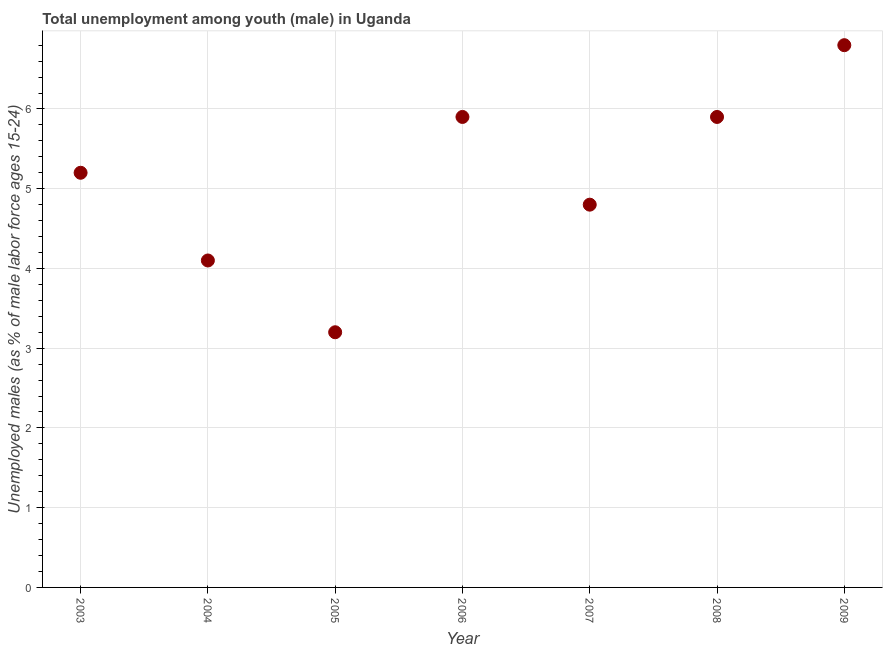What is the unemployed male youth population in 2007?
Make the answer very short. 4.8. Across all years, what is the maximum unemployed male youth population?
Your response must be concise. 6.8. Across all years, what is the minimum unemployed male youth population?
Your answer should be compact. 3.2. In which year was the unemployed male youth population minimum?
Offer a terse response. 2005. What is the sum of the unemployed male youth population?
Your answer should be very brief. 35.9. What is the difference between the unemployed male youth population in 2005 and 2006?
Your answer should be very brief. -2.7. What is the average unemployed male youth population per year?
Give a very brief answer. 5.13. What is the median unemployed male youth population?
Make the answer very short. 5.2. In how many years, is the unemployed male youth population greater than 1.8 %?
Offer a terse response. 7. What is the ratio of the unemployed male youth population in 2005 to that in 2008?
Your response must be concise. 0.54. Is the difference between the unemployed male youth population in 2005 and 2007 greater than the difference between any two years?
Provide a short and direct response. No. What is the difference between the highest and the second highest unemployed male youth population?
Give a very brief answer. 0.9. Is the sum of the unemployed male youth population in 2006 and 2007 greater than the maximum unemployed male youth population across all years?
Make the answer very short. Yes. What is the difference between the highest and the lowest unemployed male youth population?
Your response must be concise. 3.6. Are the values on the major ticks of Y-axis written in scientific E-notation?
Offer a very short reply. No. What is the title of the graph?
Make the answer very short. Total unemployment among youth (male) in Uganda. What is the label or title of the X-axis?
Keep it short and to the point. Year. What is the label or title of the Y-axis?
Ensure brevity in your answer.  Unemployed males (as % of male labor force ages 15-24). What is the Unemployed males (as % of male labor force ages 15-24) in 2003?
Keep it short and to the point. 5.2. What is the Unemployed males (as % of male labor force ages 15-24) in 2004?
Your answer should be compact. 4.1. What is the Unemployed males (as % of male labor force ages 15-24) in 2005?
Your response must be concise. 3.2. What is the Unemployed males (as % of male labor force ages 15-24) in 2006?
Provide a short and direct response. 5.9. What is the Unemployed males (as % of male labor force ages 15-24) in 2007?
Ensure brevity in your answer.  4.8. What is the Unemployed males (as % of male labor force ages 15-24) in 2008?
Provide a short and direct response. 5.9. What is the Unemployed males (as % of male labor force ages 15-24) in 2009?
Keep it short and to the point. 6.8. What is the difference between the Unemployed males (as % of male labor force ages 15-24) in 2003 and 2007?
Provide a short and direct response. 0.4. What is the difference between the Unemployed males (as % of male labor force ages 15-24) in 2003 and 2009?
Your answer should be very brief. -1.6. What is the difference between the Unemployed males (as % of male labor force ages 15-24) in 2004 and 2005?
Provide a short and direct response. 0.9. What is the difference between the Unemployed males (as % of male labor force ages 15-24) in 2004 and 2006?
Keep it short and to the point. -1.8. What is the difference between the Unemployed males (as % of male labor force ages 15-24) in 2004 and 2007?
Provide a short and direct response. -0.7. What is the difference between the Unemployed males (as % of male labor force ages 15-24) in 2004 and 2009?
Your response must be concise. -2.7. What is the difference between the Unemployed males (as % of male labor force ages 15-24) in 2005 and 2006?
Provide a succinct answer. -2.7. What is the difference between the Unemployed males (as % of male labor force ages 15-24) in 2005 and 2008?
Keep it short and to the point. -2.7. What is the difference between the Unemployed males (as % of male labor force ages 15-24) in 2005 and 2009?
Give a very brief answer. -3.6. What is the difference between the Unemployed males (as % of male labor force ages 15-24) in 2006 and 2007?
Offer a very short reply. 1.1. What is the difference between the Unemployed males (as % of male labor force ages 15-24) in 2006 and 2008?
Make the answer very short. 0. What is the difference between the Unemployed males (as % of male labor force ages 15-24) in 2006 and 2009?
Your answer should be compact. -0.9. What is the difference between the Unemployed males (as % of male labor force ages 15-24) in 2007 and 2008?
Keep it short and to the point. -1.1. What is the difference between the Unemployed males (as % of male labor force ages 15-24) in 2007 and 2009?
Give a very brief answer. -2. What is the ratio of the Unemployed males (as % of male labor force ages 15-24) in 2003 to that in 2004?
Provide a succinct answer. 1.27. What is the ratio of the Unemployed males (as % of male labor force ages 15-24) in 2003 to that in 2005?
Provide a succinct answer. 1.62. What is the ratio of the Unemployed males (as % of male labor force ages 15-24) in 2003 to that in 2006?
Make the answer very short. 0.88. What is the ratio of the Unemployed males (as % of male labor force ages 15-24) in 2003 to that in 2007?
Provide a short and direct response. 1.08. What is the ratio of the Unemployed males (as % of male labor force ages 15-24) in 2003 to that in 2008?
Your response must be concise. 0.88. What is the ratio of the Unemployed males (as % of male labor force ages 15-24) in 2003 to that in 2009?
Provide a succinct answer. 0.77. What is the ratio of the Unemployed males (as % of male labor force ages 15-24) in 2004 to that in 2005?
Give a very brief answer. 1.28. What is the ratio of the Unemployed males (as % of male labor force ages 15-24) in 2004 to that in 2006?
Keep it short and to the point. 0.69. What is the ratio of the Unemployed males (as % of male labor force ages 15-24) in 2004 to that in 2007?
Provide a short and direct response. 0.85. What is the ratio of the Unemployed males (as % of male labor force ages 15-24) in 2004 to that in 2008?
Your answer should be compact. 0.69. What is the ratio of the Unemployed males (as % of male labor force ages 15-24) in 2004 to that in 2009?
Provide a succinct answer. 0.6. What is the ratio of the Unemployed males (as % of male labor force ages 15-24) in 2005 to that in 2006?
Give a very brief answer. 0.54. What is the ratio of the Unemployed males (as % of male labor force ages 15-24) in 2005 to that in 2007?
Keep it short and to the point. 0.67. What is the ratio of the Unemployed males (as % of male labor force ages 15-24) in 2005 to that in 2008?
Your response must be concise. 0.54. What is the ratio of the Unemployed males (as % of male labor force ages 15-24) in 2005 to that in 2009?
Your response must be concise. 0.47. What is the ratio of the Unemployed males (as % of male labor force ages 15-24) in 2006 to that in 2007?
Keep it short and to the point. 1.23. What is the ratio of the Unemployed males (as % of male labor force ages 15-24) in 2006 to that in 2009?
Your answer should be very brief. 0.87. What is the ratio of the Unemployed males (as % of male labor force ages 15-24) in 2007 to that in 2008?
Your answer should be compact. 0.81. What is the ratio of the Unemployed males (as % of male labor force ages 15-24) in 2007 to that in 2009?
Ensure brevity in your answer.  0.71. What is the ratio of the Unemployed males (as % of male labor force ages 15-24) in 2008 to that in 2009?
Offer a very short reply. 0.87. 